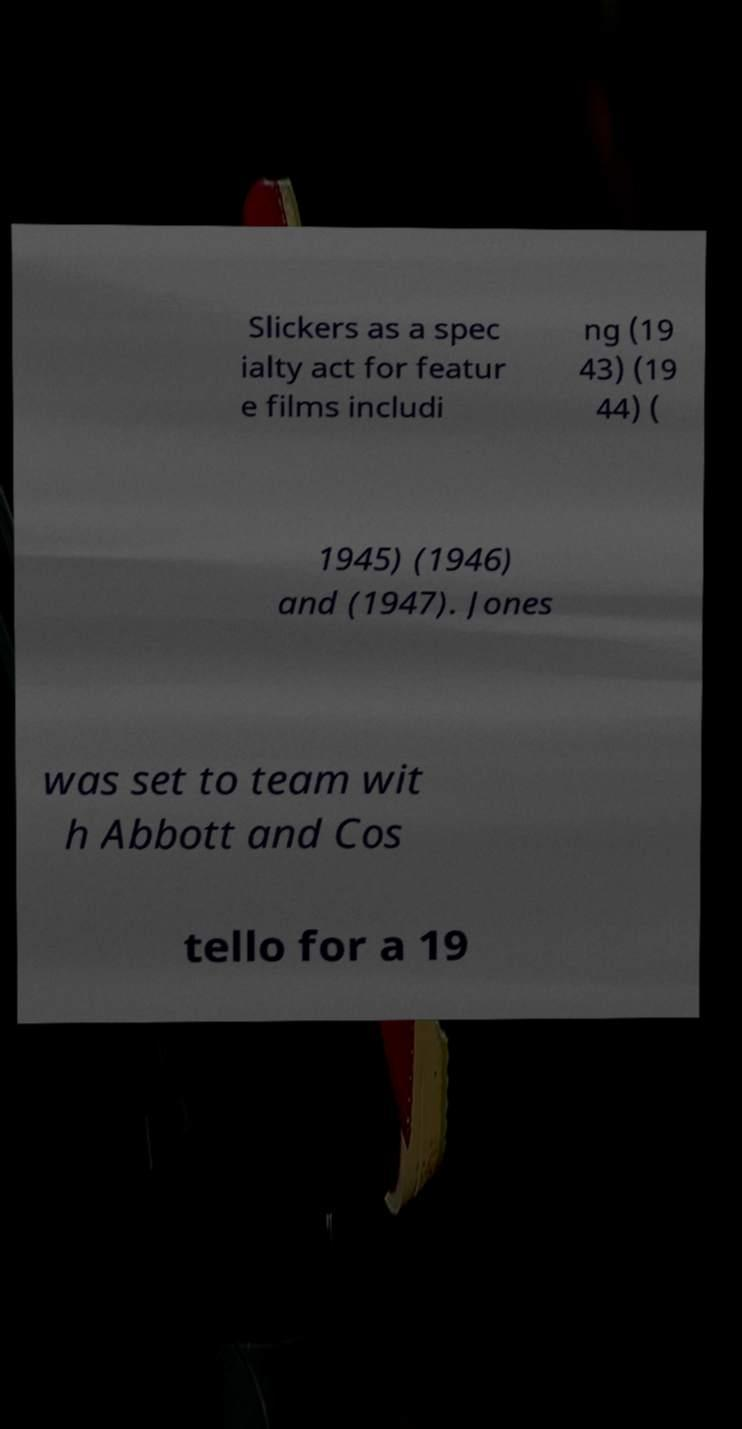Can you read and provide the text displayed in the image?This photo seems to have some interesting text. Can you extract and type it out for me? Slickers as a spec ialty act for featur e films includi ng (19 43) (19 44) ( 1945) (1946) and (1947). Jones was set to team wit h Abbott and Cos tello for a 19 